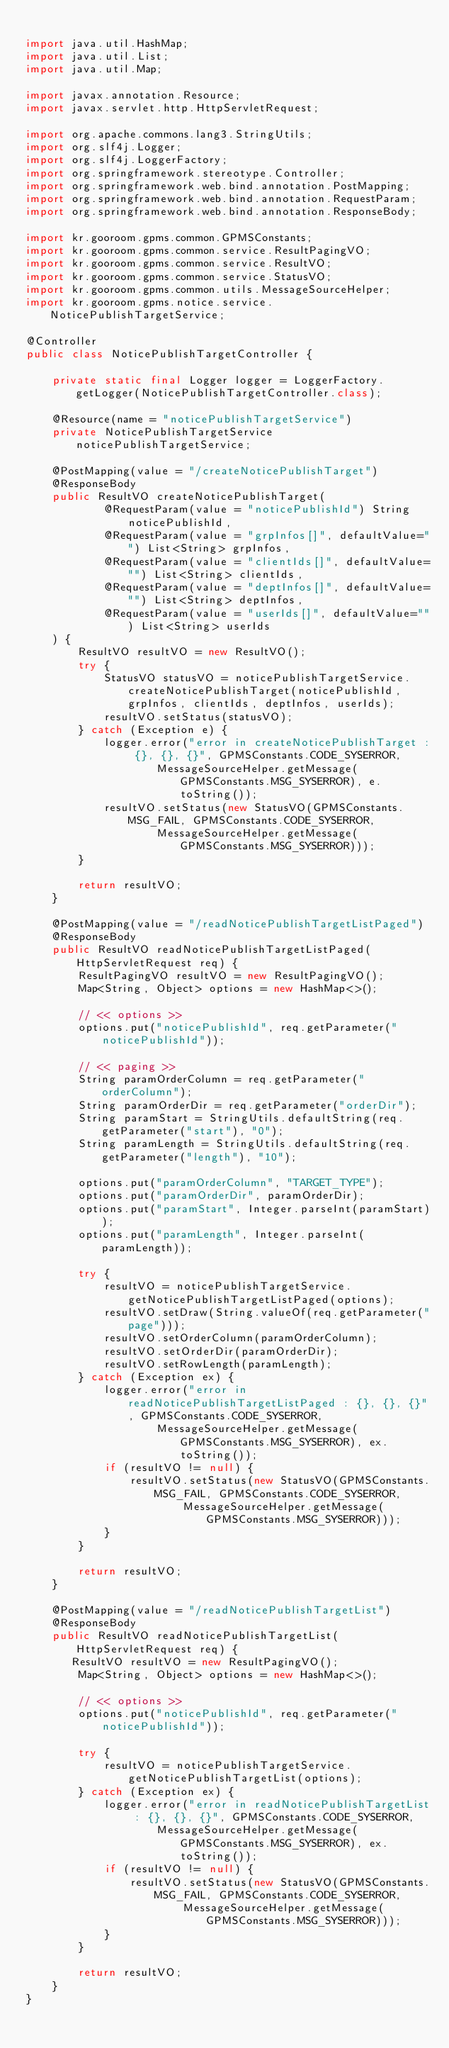Convert code to text. <code><loc_0><loc_0><loc_500><loc_500><_Java_>
import java.util.HashMap;
import java.util.List;
import java.util.Map;

import javax.annotation.Resource;
import javax.servlet.http.HttpServletRequest;

import org.apache.commons.lang3.StringUtils;
import org.slf4j.Logger;
import org.slf4j.LoggerFactory;
import org.springframework.stereotype.Controller;
import org.springframework.web.bind.annotation.PostMapping;
import org.springframework.web.bind.annotation.RequestParam;
import org.springframework.web.bind.annotation.ResponseBody;

import kr.gooroom.gpms.common.GPMSConstants;
import kr.gooroom.gpms.common.service.ResultPagingVO;
import kr.gooroom.gpms.common.service.ResultVO;
import kr.gooroom.gpms.common.service.StatusVO;
import kr.gooroom.gpms.common.utils.MessageSourceHelper;
import kr.gooroom.gpms.notice.service.NoticePublishTargetService;

@Controller
public class NoticePublishTargetController {

	private static final Logger logger = LoggerFactory.getLogger(NoticePublishTargetController.class);
	
	@Resource(name = "noticePublishTargetService")
	private NoticePublishTargetService noticePublishTargetService;

	@PostMapping(value = "/createNoticePublishTarget")
	@ResponseBody
	public ResultVO createNoticePublishTarget(
	        @RequestParam(value = "noticePublishId") String noticePublishId,
	        @RequestParam(value = "grpInfos[]", defaultValue="") List<String> grpInfos,
            @RequestParam(value = "clientIds[]", defaultValue="") List<String> clientIds,
            @RequestParam(value = "deptInfos[]", defaultValue="") List<String> deptInfos,
            @RequestParam(value = "userIds[]", defaultValue="") List<String> userIds
    ) {
	    ResultVO resultVO = new ResultVO();
	    try {
	        StatusVO statusVO = noticePublishTargetService.createNoticePublishTarget(noticePublishId, grpInfos, clientIds, deptInfos, userIds);
	        resultVO.setStatus(statusVO);
	    } catch (Exception e) {
            logger.error("error in createNoticePublishTarget : {}, {}, {}", GPMSConstants.CODE_SYSERROR,
                    MessageSourceHelper.getMessage(GPMSConstants.MSG_SYSERROR), e.toString());
            resultVO.setStatus(new StatusVO(GPMSConstants.MSG_FAIL, GPMSConstants.CODE_SYSERROR,
                    MessageSourceHelper.getMessage(GPMSConstants.MSG_SYSERROR)));
        }

	    return resultVO;
	}

	@PostMapping(value = "/readNoticePublishTargetListPaged")
	@ResponseBody
	public ResultVO readNoticePublishTargetListPaged(HttpServletRequest req) {
	    ResultPagingVO resultVO = new ResultPagingVO();
        Map<String, Object> options = new HashMap<>();
        
        // << options >>
        options.put("noticePublishId", req.getParameter("noticePublishId"));
        
        // << paging >>
        String paramOrderColumn = req.getParameter("orderColumn");
        String paramOrderDir = req.getParameter("orderDir");
        String paramStart = StringUtils.defaultString(req.getParameter("start"), "0");
        String paramLength = StringUtils.defaultString(req.getParameter("length"), "10");

        options.put("paramOrderColumn", "TARGET_TYPE");
        options.put("paramOrderDir", paramOrderDir);
        options.put("paramStart", Integer.parseInt(paramStart));
        options.put("paramLength", Integer.parseInt(paramLength));

		try {
			resultVO = noticePublishTargetService.getNoticePublishTargetListPaged(options);
            resultVO.setDraw(String.valueOf(req.getParameter("page")));
            resultVO.setOrderColumn(paramOrderColumn);
            resultVO.setOrderDir(paramOrderDir);
            resultVO.setRowLength(paramLength);
		} catch (Exception ex) {
		    logger.error("error in readNoticePublishTargetListPaged : {}, {}, {}", GPMSConstants.CODE_SYSERROR,
		    		MessageSourceHelper.getMessage(GPMSConstants.MSG_SYSERROR), ex.toString());
		    if (resultVO != null) {
		    	resultVO.setStatus(new StatusVO(GPMSConstants.MSG_FAIL, GPMSConstants.CODE_SYSERROR,
		    			MessageSourceHelper.getMessage(GPMSConstants.MSG_SYSERROR)));
	    	}
	    }
		
		return resultVO;
	}

	@PostMapping(value = "/readNoticePublishTargetList")
    @ResponseBody
    public ResultVO readNoticePublishTargetList(HttpServletRequest req) {
       ResultVO resultVO = new ResultPagingVO();
        Map<String, Object> options = new HashMap<>();
        
        // << options >>
        options.put("noticePublishId", req.getParameter("noticePublishId"));

        try {
            resultVO = noticePublishTargetService.getNoticePublishTargetList(options);
        } catch (Exception ex) {
            logger.error("error in readNoticePublishTargetList : {}, {}, {}", GPMSConstants.CODE_SYSERROR,
                    MessageSourceHelper.getMessage(GPMSConstants.MSG_SYSERROR), ex.toString());
            if (resultVO != null) {
                resultVO.setStatus(new StatusVO(GPMSConstants.MSG_FAIL, GPMSConstants.CODE_SYSERROR,
                        MessageSourceHelper.getMessage(GPMSConstants.MSG_SYSERROR)));
            }
        }
        
        return resultVO;
    }
}</code> 